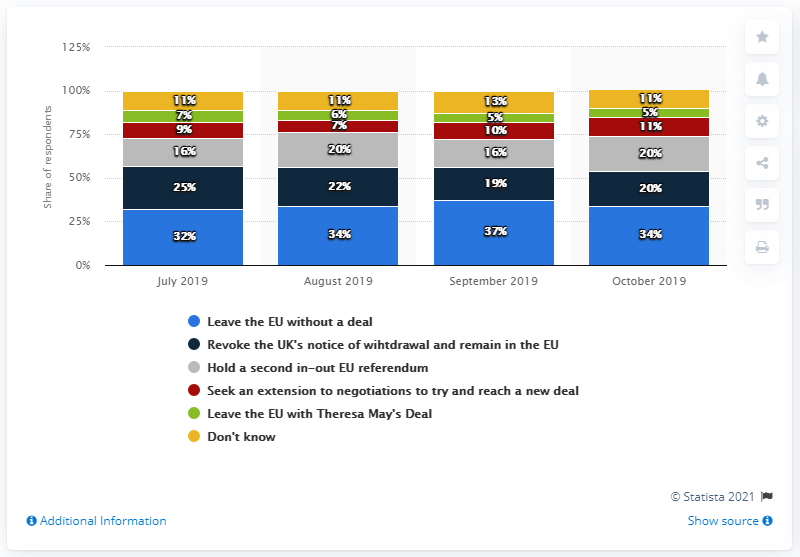Draw attention to some important aspects in this diagram. As of September 2019, the most preferred option for Brexit is to leave the EU without a deal. A recent survey in Great Britain revealed that 34% of the population supports a no-deal Brexit. In September 2019, the respondents were more interested in the "Leave the EU" option, whether or not it included Theresa May's deal. 